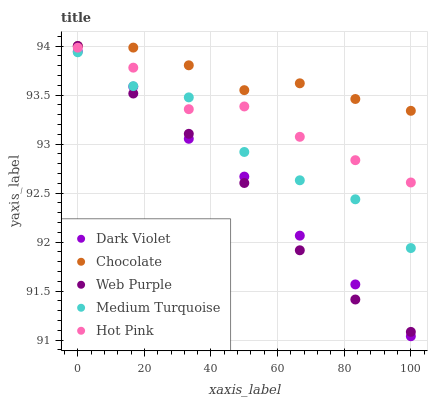Does Web Purple have the minimum area under the curve?
Answer yes or no. Yes. Does Chocolate have the maximum area under the curve?
Answer yes or no. Yes. Does Hot Pink have the minimum area under the curve?
Answer yes or no. No. Does Hot Pink have the maximum area under the curve?
Answer yes or no. No. Is Dark Violet the smoothest?
Answer yes or no. Yes. Is Medium Turquoise the roughest?
Answer yes or no. Yes. Is Hot Pink the smoothest?
Answer yes or no. No. Is Hot Pink the roughest?
Answer yes or no. No. Does Dark Violet have the lowest value?
Answer yes or no. Yes. Does Hot Pink have the lowest value?
Answer yes or no. No. Does Chocolate have the highest value?
Answer yes or no. Yes. Does Hot Pink have the highest value?
Answer yes or no. No. Is Medium Turquoise less than Chocolate?
Answer yes or no. Yes. Is Chocolate greater than Dark Violet?
Answer yes or no. Yes. Does Hot Pink intersect Web Purple?
Answer yes or no. Yes. Is Hot Pink less than Web Purple?
Answer yes or no. No. Is Hot Pink greater than Web Purple?
Answer yes or no. No. Does Medium Turquoise intersect Chocolate?
Answer yes or no. No. 